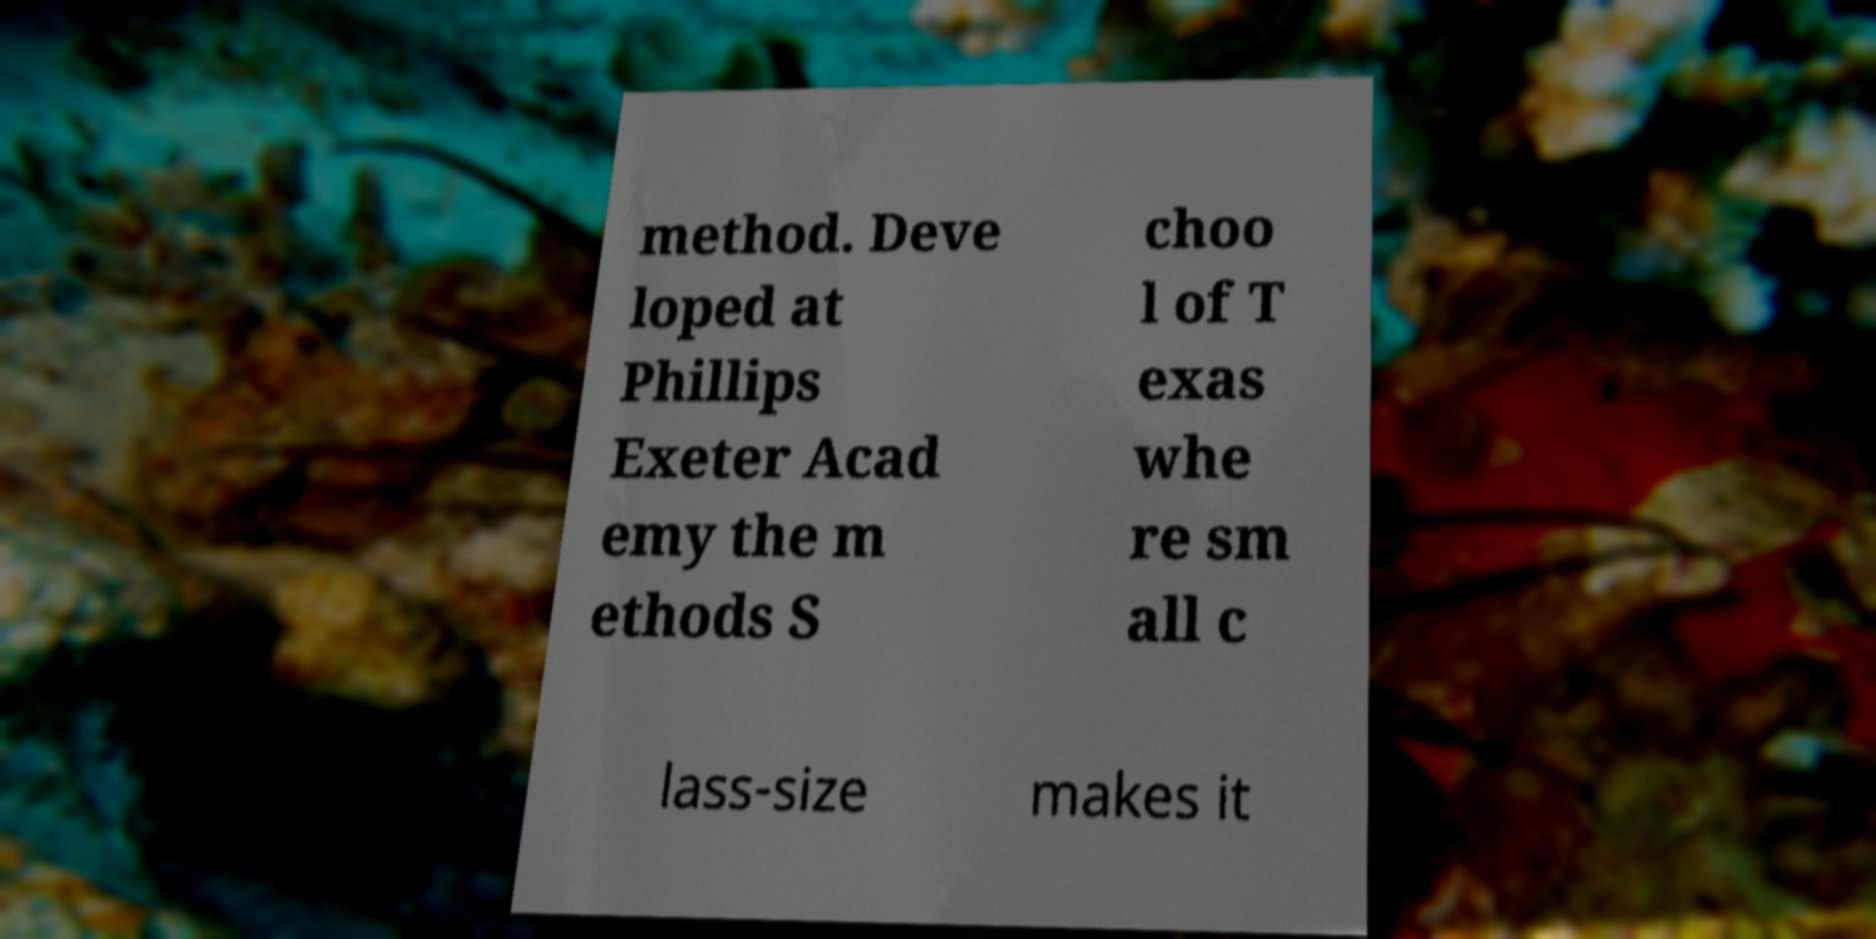I need the written content from this picture converted into text. Can you do that? method. Deve loped at Phillips Exeter Acad emy the m ethods S choo l of T exas whe re sm all c lass-size makes it 